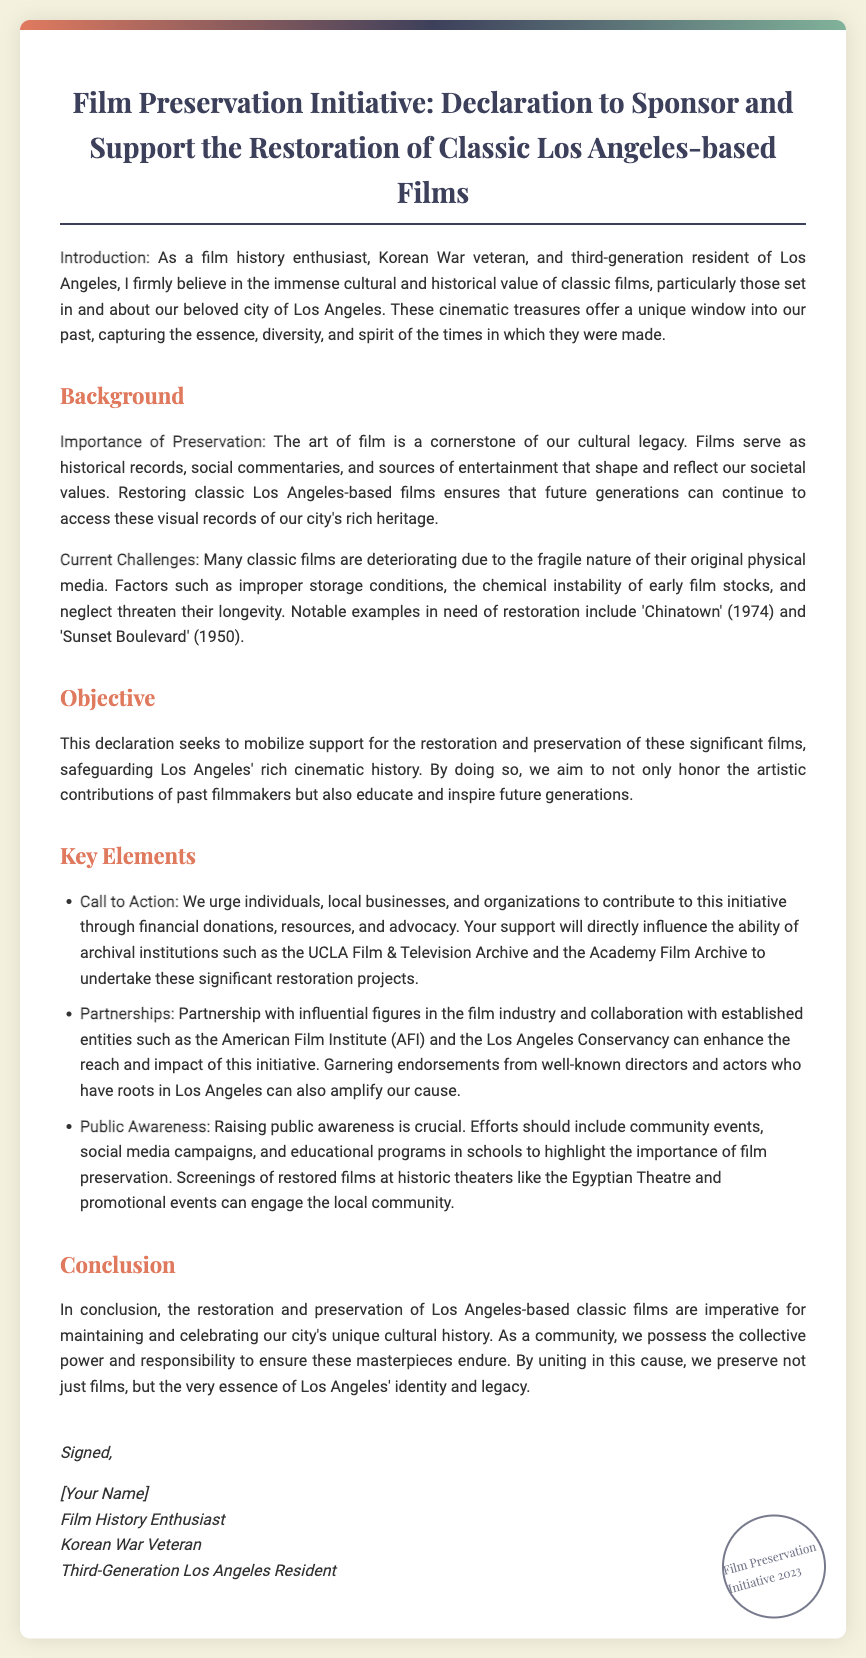What is the title of the declaration? The title of the declaration is stated at the beginning of the document.
Answer: Film Preservation Initiative: Declaration to Sponsor and Support the Restoration of Classic Los Angeles-based Films What year is mentioned in the stamp? The stamp at the bottom of the document indicates the year associated with the initiative.
Answer: 2023 What notable film from 1974 is mentioned as needing restoration? The document lists specific films that require restoration as examples of classic films.
Answer: Chinatown Who is urged to contribute to the initiative? The declaration outlines who should be involved in supporting the film preservation initiative.
Answer: Individuals, local businesses, and organizations What is one key element mentioned in the declaration? The declaration includes several key elements that outline the initiative's strategy and goals.
Answer: Call to Action What does the initiative aim to educate future generations about? The document states a clear objective related to education regarding cultural heritage through film.
Answer: Preservation of significant films What is described as a cornerstone of our cultural legacy? The document asserts the importance of a particular art form in relationship to culture and history.
Answer: The art of film What type of events are suggested to raise public awareness? The text provides suggestions on how to engage the community and promote awareness for the initiative.
Answer: Community events 